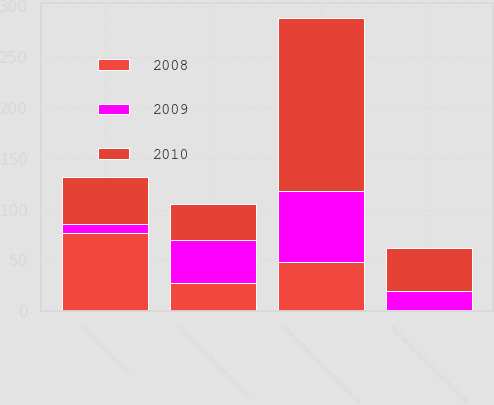<chart> <loc_0><loc_0><loc_500><loc_500><stacked_bar_chart><ecel><fcel>Net unrealized gains/losses on<fcel>Net unrecognized gains/losses<fcel>Cumulative foreign currency<fcel>Accumulated other<nl><fcel>2010<fcel>171<fcel>42<fcel>35<fcel>46<nl><fcel>2008<fcel>48<fcel>1<fcel>28<fcel>77<nl><fcel>2009<fcel>70<fcel>19<fcel>42<fcel>9<nl></chart> 